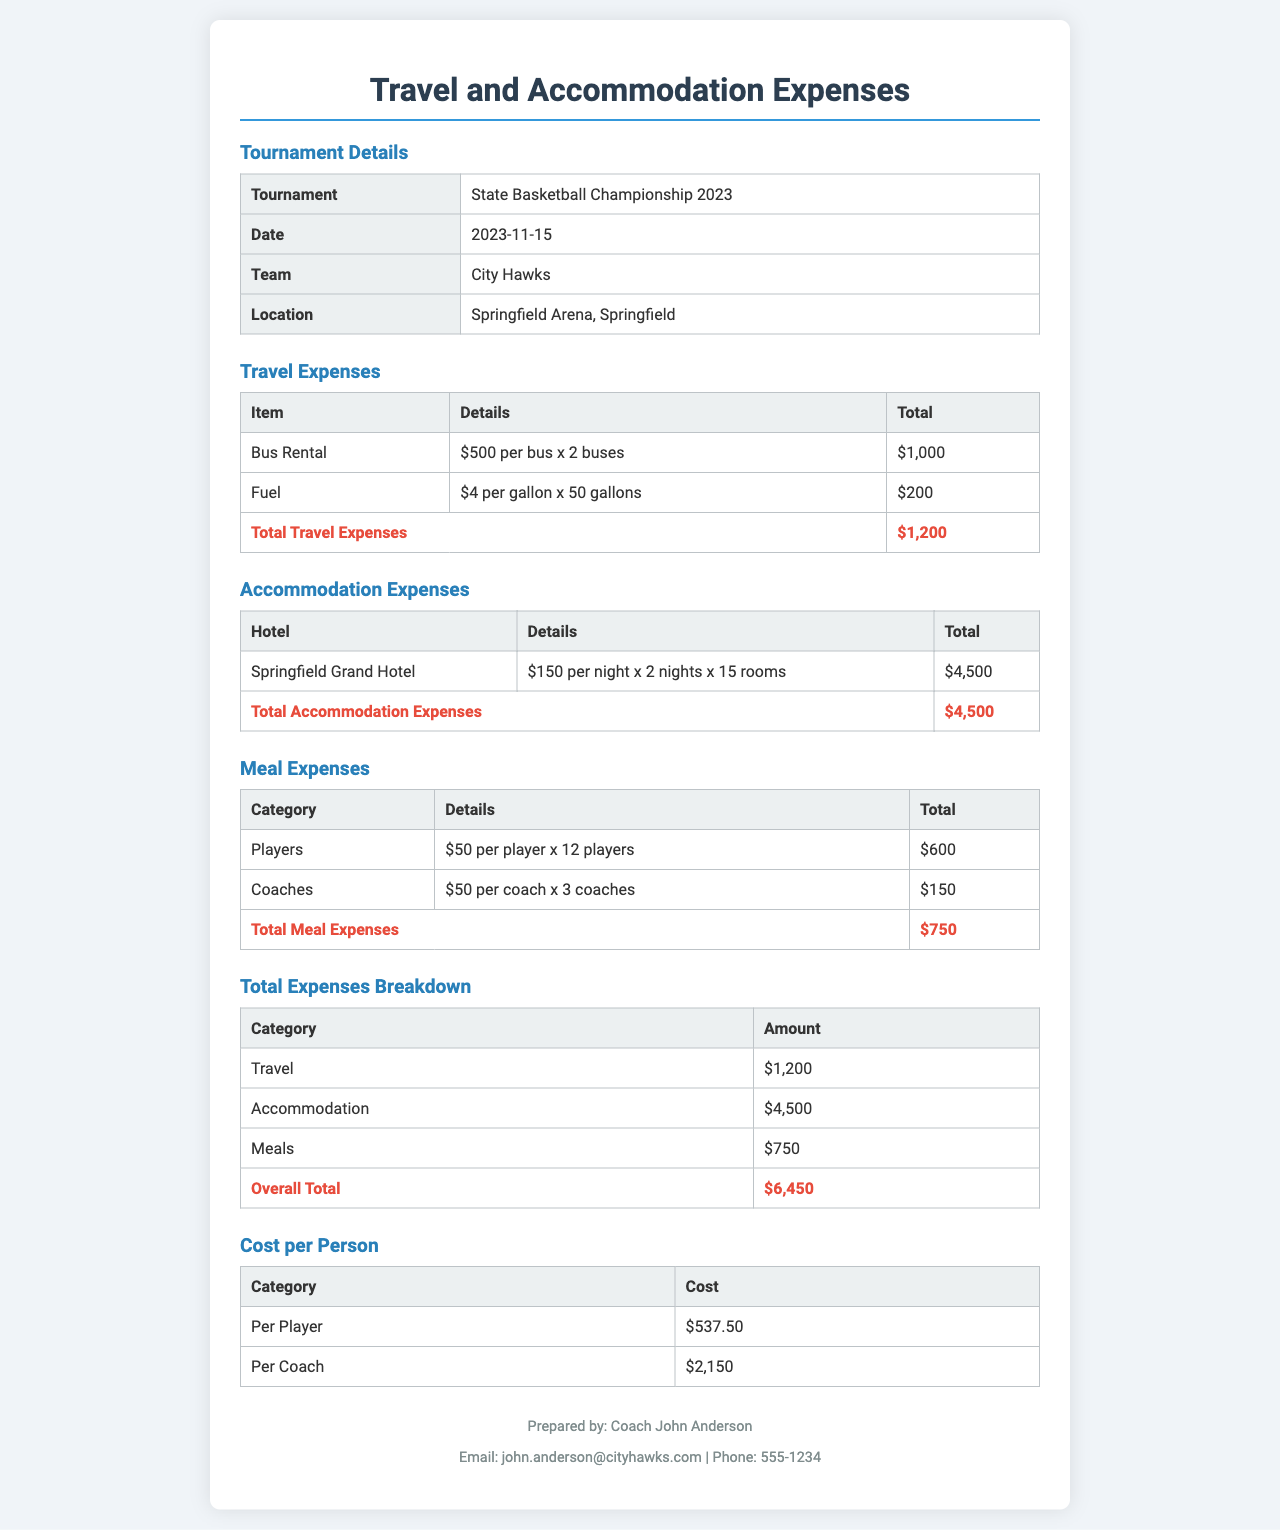what is the total travel expense? The total travel expense is presented in the travel expenses section, which is $1,200.
Answer: $1,200 how much does each player cost? The cost per player is detailed in the "Cost per Person" section, which states $537.50.
Answer: $537.50 what is the hotel name for accommodation? The hotel name is provided in the accommodation expenses section, which is Springfield Grand Hotel.
Answer: Springfield Grand Hotel how many coaches are included in the meal expenses? The meal expenses section specifies there are 3 coaches included.
Answer: 3 coaches what is the total number of players? The meal expenses section indicates there are 12 players included.
Answer: 12 players what is the total accommodation expense? The total accommodation expense is listed in the accommodation expenses section, which is $4,500.
Answer: $4,500 what is the overall total of all expenses? The overall total can be found in the total expenses breakdown section, which is $6,450.
Answer: $6,450 how many rooms were booked for accommodation? The accommodation section states that 15 rooms were booked.
Answer: 15 rooms how much did fuel cost? The fuel cost is detailed in the travel expenses section, which is $200.
Answer: $200 